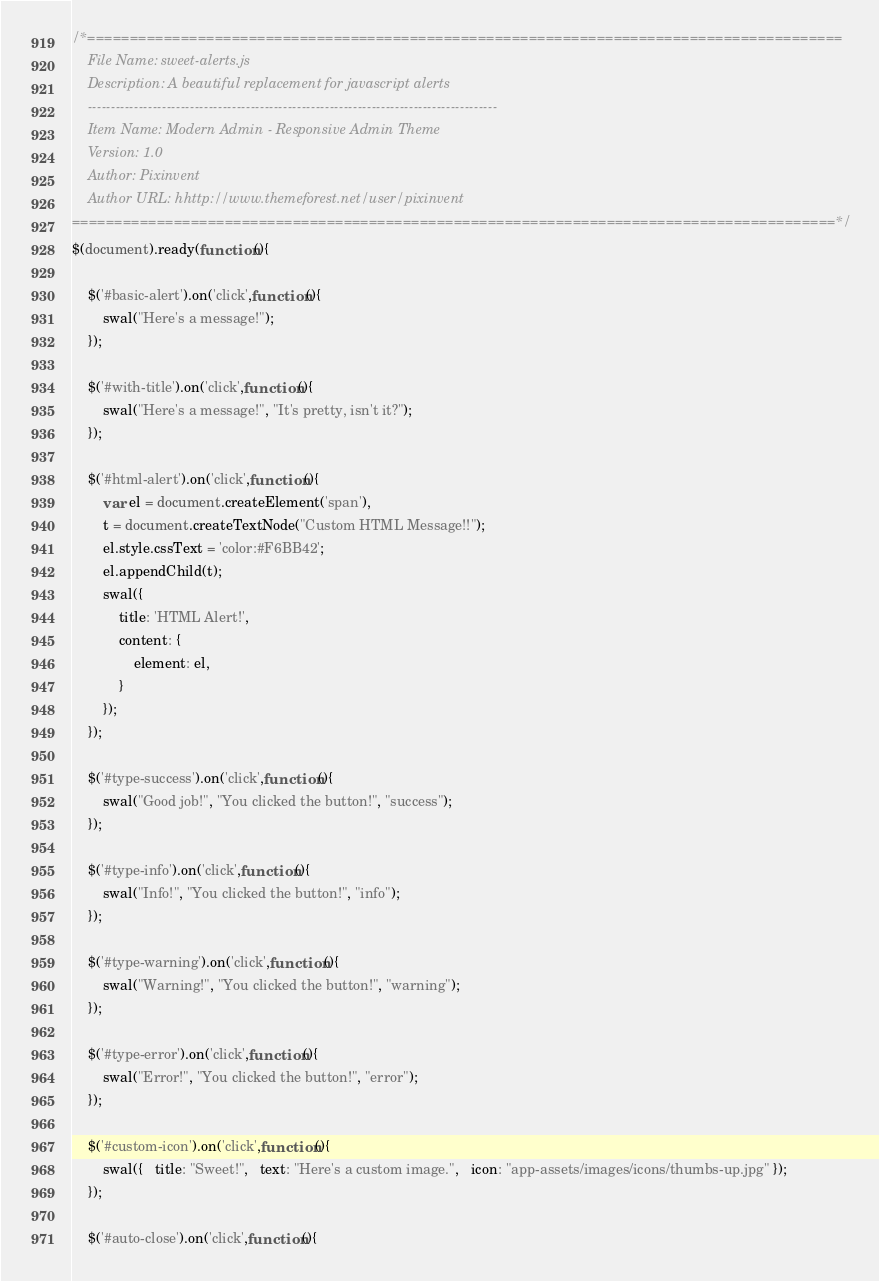<code> <loc_0><loc_0><loc_500><loc_500><_JavaScript_>/*=========================================================================================
	File Name: sweet-alerts.js
	Description: A beautiful replacement for javascript alerts
	----------------------------------------------------------------------------------------
	Item Name: Modern Admin - Responsive Admin Theme
	Version: 1.0
	Author: Pixinvent
	Author URL: hhttp://www.themeforest.net/user/pixinvent
==========================================================================================*/
$(document).ready(function(){

	$('#basic-alert').on('click',function(){
		swal("Here's a message!");
	});

	$('#with-title').on('click',function(){
		swal("Here's a message!", "It's pretty, isn't it?");
	});

	$('#html-alert').on('click',function(){
		var el = document.createElement('span'),
		t = document.createTextNode("Custom HTML Message!!");
		el.style.cssText = 'color:#F6BB42';
		el.appendChild(t);
		swal({
			title: 'HTML Alert!',
			content: {
				element: el,
			}
		});
	});

	$('#type-success').on('click',function(){
		swal("Good job!", "You clicked the button!", "success");
	});

	$('#type-info').on('click',function(){
		swal("Info!", "You clicked the button!", "info");
	});

	$('#type-warning').on('click',function(){
		swal("Warning!", "You clicked the button!", "warning");
	});

	$('#type-error').on('click',function(){
		swal("Error!", "You clicked the button!", "error");
	});

	$('#custom-icon').on('click',function(){
		swal({   title: "Sweet!",   text: "Here's a custom image.",   icon: "app-assets/images/icons/thumbs-up.jpg" });
	});

	$('#auto-close').on('click',function(){</code> 